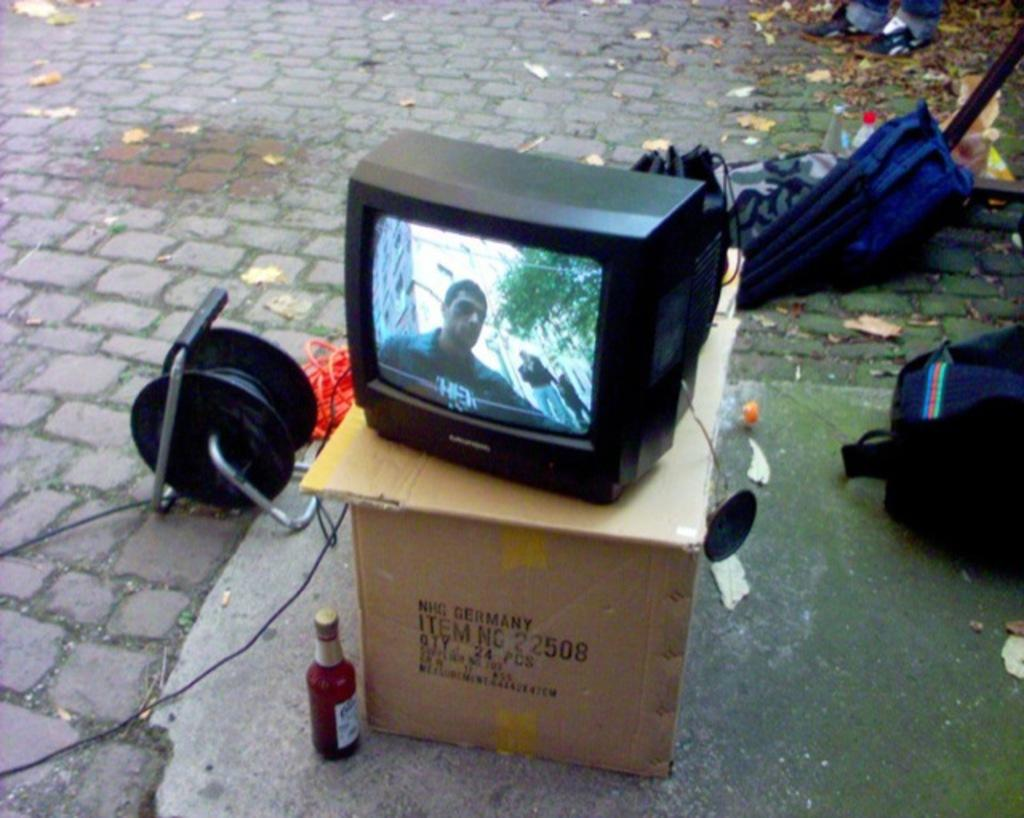What can be seen on the ground in the image? There are objects on the ground in the image, including a cotton box, bottles, bags, and leaves. Can you describe the cotton box in the image? Yes, there is a cotton box among the objects on the ground. What else is present among the objects on the ground? There are bottles and bags among the objects on the ground. What type of vegetation is present among the objects on the ground? There are leaves among the objects on the ground. What is placed on top of the cotton box in the image? There is a television on the cotton box in the image. What type of railway is visible in the image? There is no railway present in the image. What type of dress is the owner wearing in the image? There is no owner or dress present in the image. 